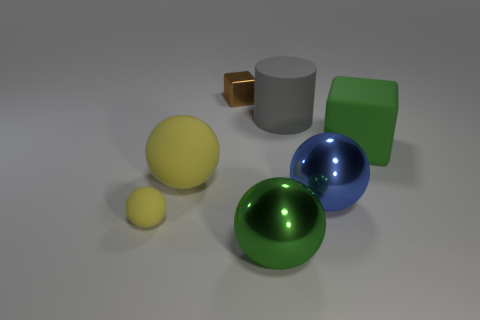Do the big metal thing on the left side of the blue ball and the cube that is in front of the small brown shiny block have the same color?
Your answer should be very brief. Yes. There is a large metal sphere in front of the ball on the right side of the big cylinder; what number of rubber things are to the right of it?
Keep it short and to the point. 2. How many metal objects are both to the left of the big cylinder and in front of the matte cylinder?
Provide a short and direct response. 1. Are there more large green matte cubes that are right of the green shiny ball than cyan balls?
Provide a short and direct response. Yes. What number of blue metal spheres have the same size as the cylinder?
Your response must be concise. 1. There is a object that is the same color as the large matte ball; what is its size?
Your answer should be compact. Small. What number of big things are brown rubber cylinders or green metal balls?
Give a very brief answer. 1. What number of large rubber objects are there?
Keep it short and to the point. 3. Are there the same number of big green cubes that are behind the small shiny object and metal things in front of the blue ball?
Offer a very short reply. No. There is a small yellow object; are there any small brown metallic things left of it?
Provide a succinct answer. No. 